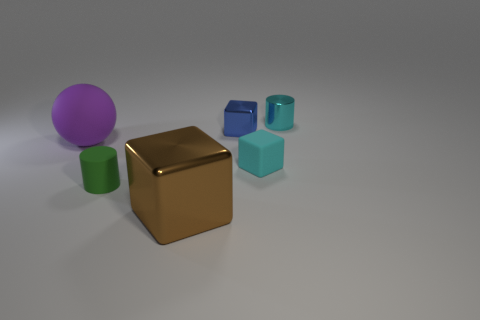Subtract all metallic cubes. How many cubes are left? 1 Add 2 big red things. How many objects exist? 8 Subtract all cylinders. How many objects are left? 4 Add 5 rubber cylinders. How many rubber cylinders exist? 6 Subtract 0 yellow cubes. How many objects are left? 6 Subtract all brown cubes. Subtract all small brown blocks. How many objects are left? 5 Add 6 cyan blocks. How many cyan blocks are left? 7 